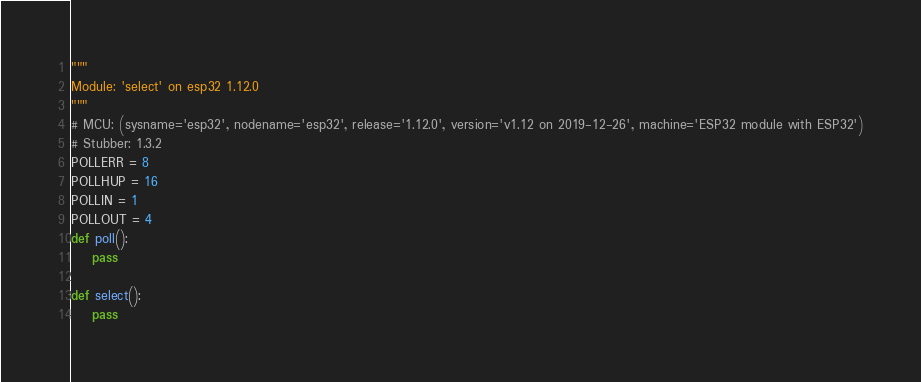<code> <loc_0><loc_0><loc_500><loc_500><_Python_>"""
Module: 'select' on esp32 1.12.0
"""
# MCU: (sysname='esp32', nodename='esp32', release='1.12.0', version='v1.12 on 2019-12-26', machine='ESP32 module with ESP32')
# Stubber: 1.3.2
POLLERR = 8
POLLHUP = 16
POLLIN = 1
POLLOUT = 4
def poll():
    pass

def select():
    pass

</code> 